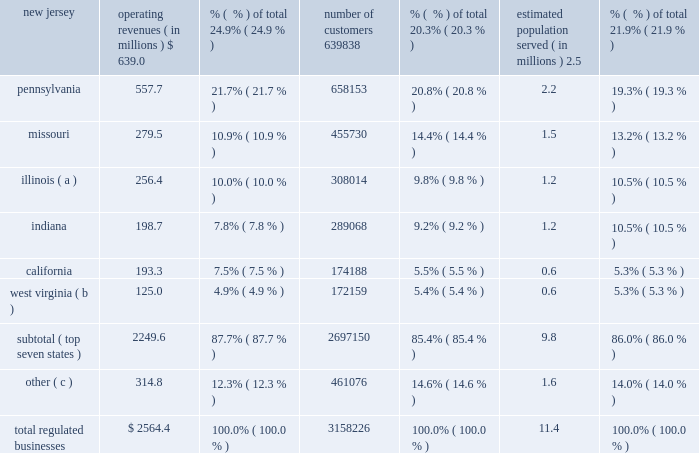As noted above , as a result of these sales , these regulated subsidiaries are presented as discontinued operations for all periods presented .
Therefore , the amounts , statistics and tables presented in this section refer only to on-going operations , unless otherwise noted .
The table sets forth our regulated businesses operating revenue for 2012 and number of customers from continuing operations as well as an estimate of population served as of december 31 , 2012 : operating revenues ( in millions ) % (  % ) of total number of customers % (  % ) of total estimated population served ( in millions ) % (  % ) of total .
( a ) includes illinois-american water company , which we refer to as ilawc and american lake water company , also a regulated subsidiary in illinois .
( b ) west virginia-american water company , which we refer to as wvawc , and its subsidiary bluefield valley water works company .
( c ) includes data from our operating subsidiaries in the following states : georgia , hawaii , iowa , kentucky , maryland , michigan , new york , tennessee , and virginia .
Approximately 87.7% ( 87.7 % ) of operating revenue from our regulated businesses in 2012 was generated from approximately 2.7 million customers in our seven largest states , as measured by operating revenues .
In fiscal year 2012 , no single customer accounted for more than 10% ( 10 % ) of our annual operating revenue .
Overview of networks , facilities and water supply our regulated businesses operate in approximately 1500 communities in 16 states in the united states .
Our primary operating assets include approximately 80 surface water treatment plants , 500 groundwater treatment plants , 1000 groundwater wells , 100 wastewater treatment facilities , 1200 treated water storage facilities , 1300 pumping stations , 90 dams and 46000 miles of mains and collection pipes .
Our regulated utilities own substantially all of the assets used by our regulated businesses .
We generally own the land and physical assets used to store , extract and treat source water .
Typically , we do not own the water itself , which is held in public trust and is allocated to us through contracts and allocation rights granted by federal and state agencies or through the ownership of water rights pursuant to local law .
Maintaining the reliability of our networks is a key activity of our regulated businesses .
We have ongoing infrastructure renewal programs in all states in which our regulated businesses operate .
These programs consist of both rehabilitation of existing mains and replacement of mains that have reached the end of their useful service lives .
Our ability to meet the existing and future water demands of our customers depends on an adequate supply of water .
Drought , governmental restrictions , overuse of sources of water , the protection of threatened species or habitats or other factors may limit the availability of ground and surface water .
We employ a variety of measures to ensure that we have adequate sources of water supply , both in the short-term and over the long-term .
The geographic diversity of our service areas tends to mitigate some of the economic effect of weather extremes we .
What is the approximate revenue per customer in the regulated businesses? 
Computations: ((2564.4 * 1000000) / 3158226)
Answer: 811.97482. 